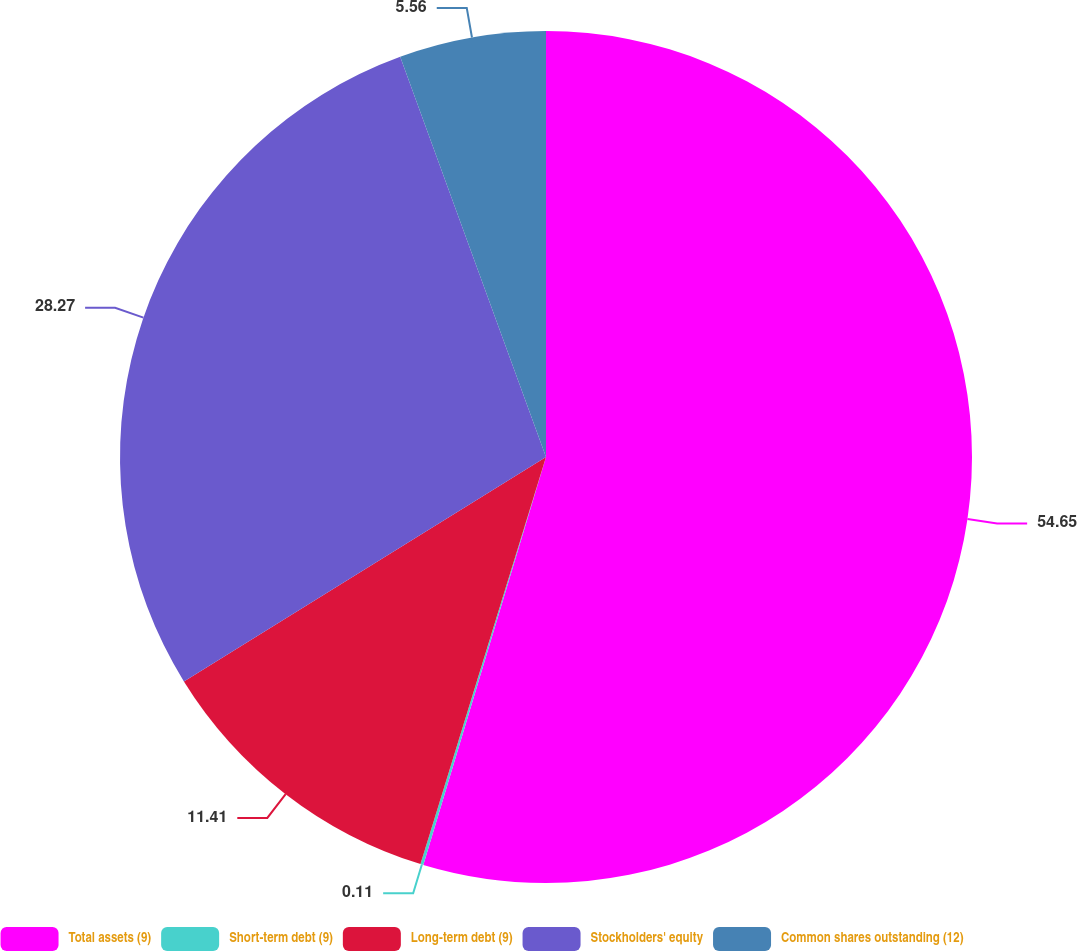Convert chart to OTSL. <chart><loc_0><loc_0><loc_500><loc_500><pie_chart><fcel>Total assets (9)<fcel>Short-term debt (9)<fcel>Long-term debt (9)<fcel>Stockholders' equity<fcel>Common shares outstanding (12)<nl><fcel>54.65%<fcel>0.11%<fcel>11.41%<fcel>28.27%<fcel>5.56%<nl></chart> 